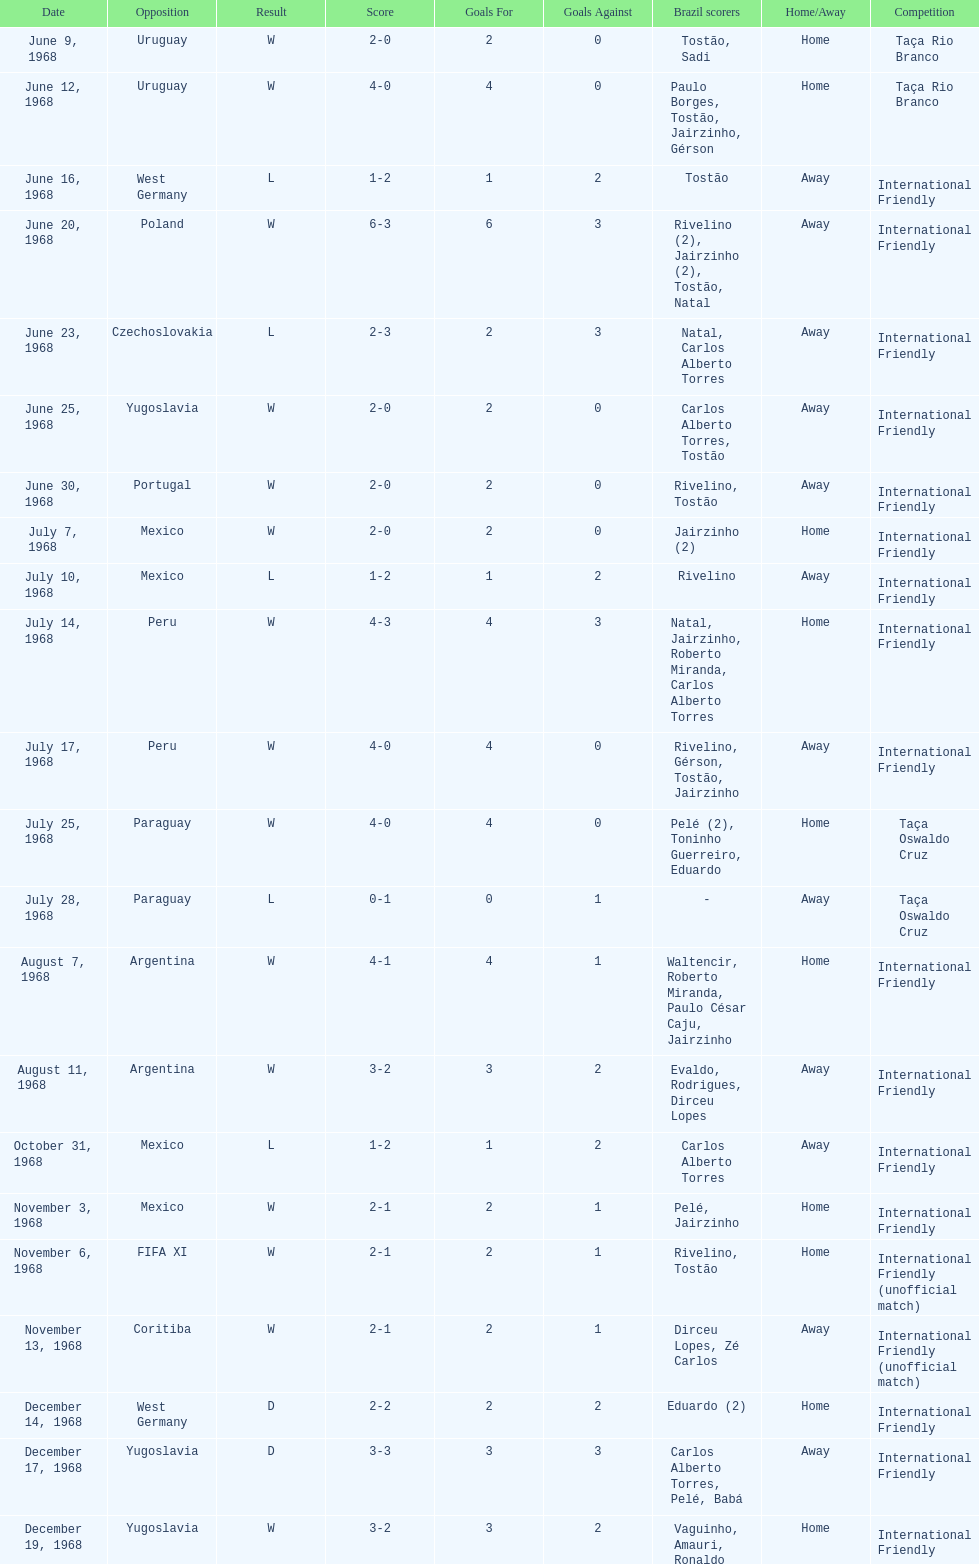What is the number of matches won? 15. 